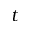Convert formula to latex. <formula><loc_0><loc_0><loc_500><loc_500>t</formula> 